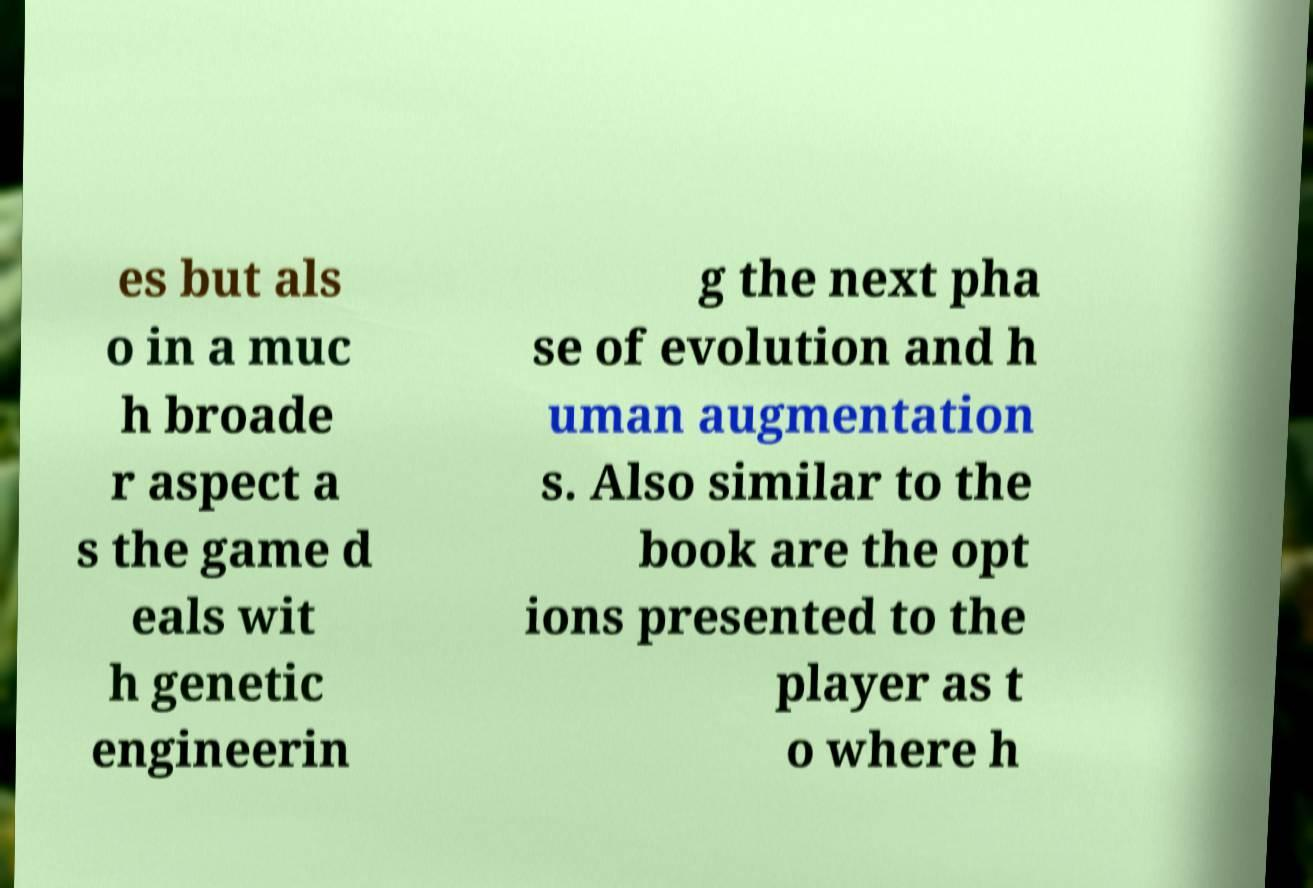What messages or text are displayed in this image? I need them in a readable, typed format. es but als o in a muc h broade r aspect a s the game d eals wit h genetic engineerin g the next pha se of evolution and h uman augmentation s. Also similar to the book are the opt ions presented to the player as t o where h 